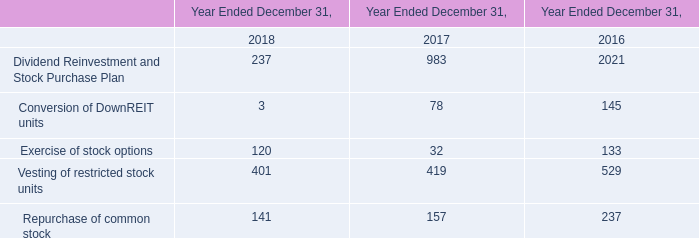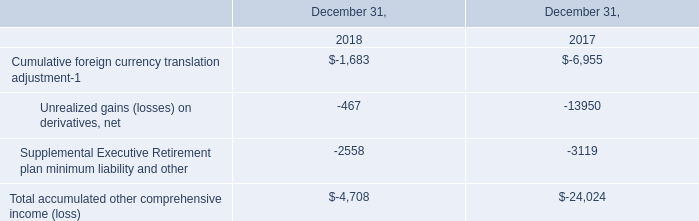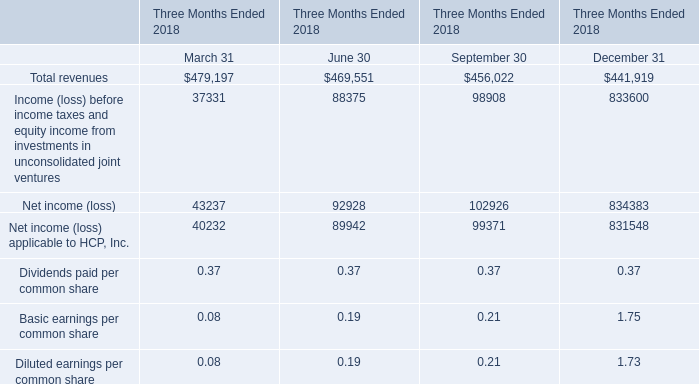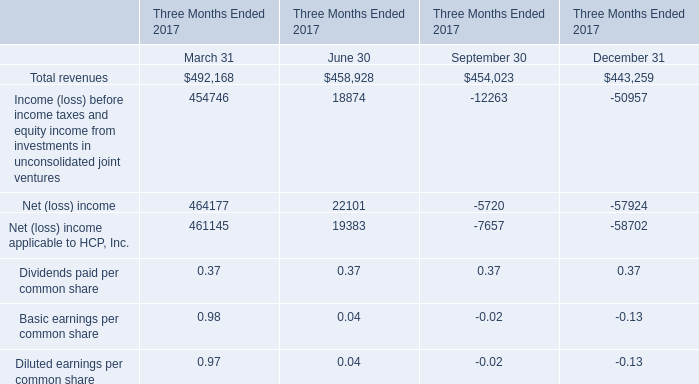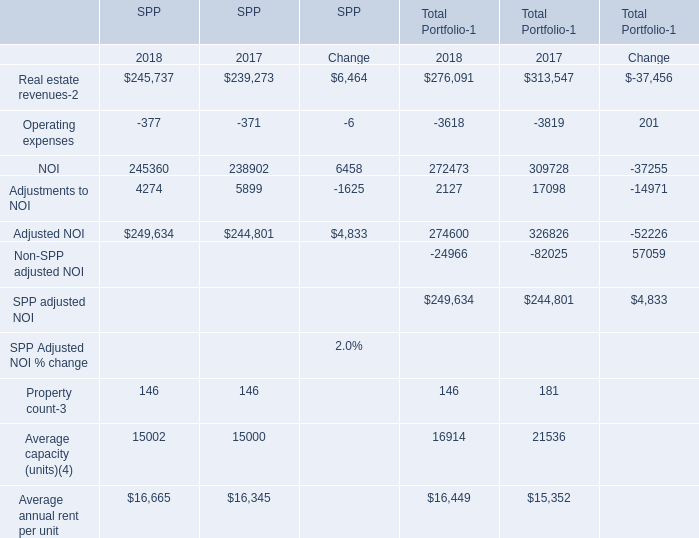What is the growing rate of Adjusted NOI of SPP in the years with the least Operating expenses of SPP? 
Computations: ((249634 - 244801) / 249634)
Answer: 0.01936. 